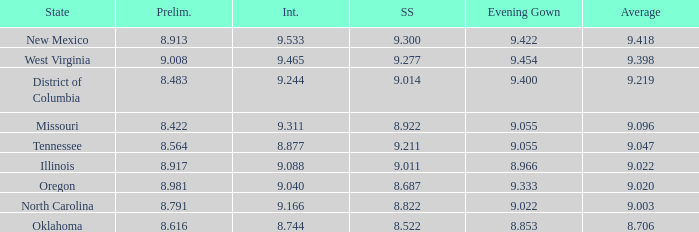Name the preliminary for north carolina 8.791. 